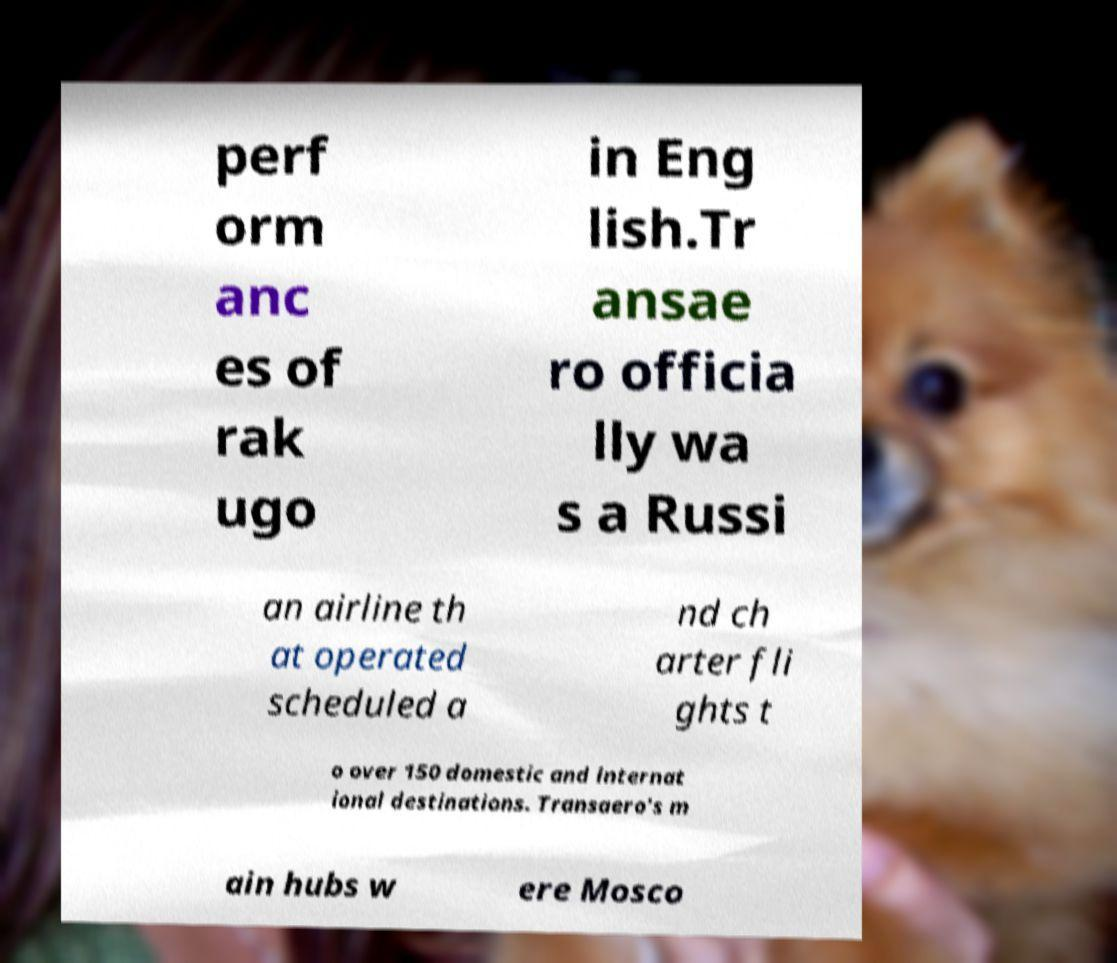Please identify and transcribe the text found in this image. perf orm anc es of rak ugo in Eng lish.Tr ansae ro officia lly wa s a Russi an airline th at operated scheduled a nd ch arter fli ghts t o over 150 domestic and internat ional destinations. Transaero's m ain hubs w ere Mosco 